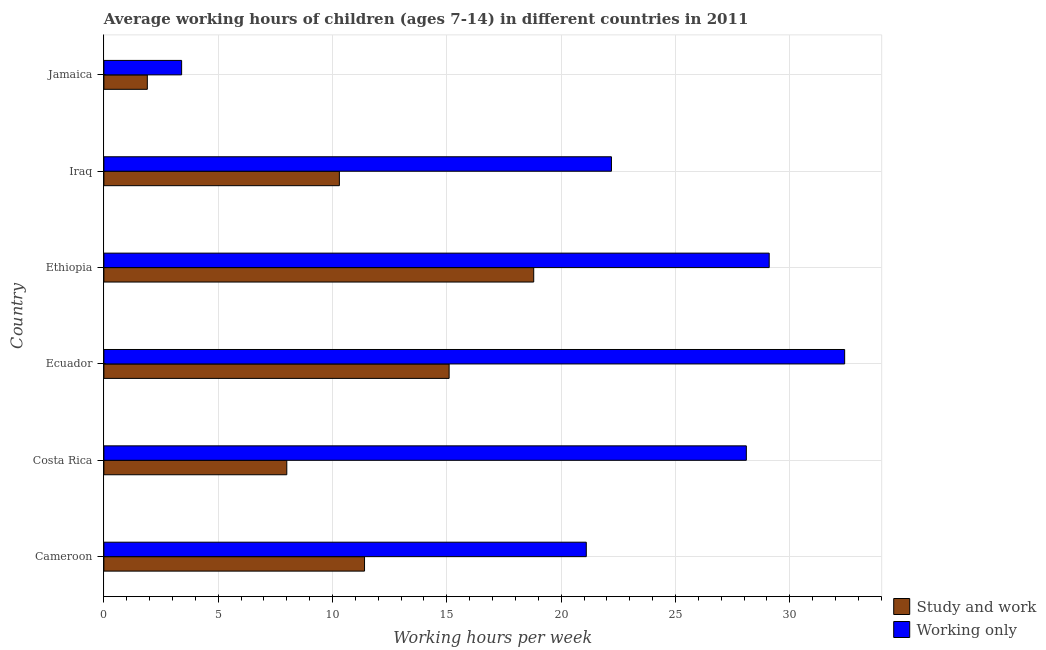Are the number of bars on each tick of the Y-axis equal?
Your response must be concise. Yes. How many bars are there on the 6th tick from the top?
Offer a terse response. 2. What is the label of the 2nd group of bars from the top?
Provide a short and direct response. Iraq. In how many cases, is the number of bars for a given country not equal to the number of legend labels?
Ensure brevity in your answer.  0. What is the average working hour of children involved in study and work in Jamaica?
Provide a short and direct response. 1.9. Across all countries, what is the minimum average working hour of children involved in only work?
Keep it short and to the point. 3.4. In which country was the average working hour of children involved in only work maximum?
Keep it short and to the point. Ecuador. In which country was the average working hour of children involved in only work minimum?
Your answer should be compact. Jamaica. What is the total average working hour of children involved in study and work in the graph?
Ensure brevity in your answer.  65.5. What is the difference between the average working hour of children involved in only work in Ecuador and that in Jamaica?
Your response must be concise. 29. What is the difference between the average working hour of children involved in only work in Ecuador and the average working hour of children involved in study and work in Costa Rica?
Make the answer very short. 24.4. What is the average average working hour of children involved in only work per country?
Provide a succinct answer. 22.72. In how many countries, is the average working hour of children involved in only work greater than 31 hours?
Keep it short and to the point. 1. What is the ratio of the average working hour of children involved in study and work in Costa Rica to that in Iraq?
Offer a very short reply. 0.78. What is the difference between the highest and the second highest average working hour of children involved in study and work?
Your response must be concise. 3.7. Is the sum of the average working hour of children involved in only work in Costa Rica and Jamaica greater than the maximum average working hour of children involved in study and work across all countries?
Your answer should be very brief. Yes. What does the 2nd bar from the top in Iraq represents?
Provide a short and direct response. Study and work. What does the 2nd bar from the bottom in Ecuador represents?
Ensure brevity in your answer.  Working only. How many bars are there?
Offer a very short reply. 12. Are all the bars in the graph horizontal?
Your response must be concise. Yes. How many countries are there in the graph?
Ensure brevity in your answer.  6. What is the difference between two consecutive major ticks on the X-axis?
Give a very brief answer. 5. Does the graph contain grids?
Provide a succinct answer. Yes. How are the legend labels stacked?
Make the answer very short. Vertical. What is the title of the graph?
Provide a succinct answer. Average working hours of children (ages 7-14) in different countries in 2011. Does "State government" appear as one of the legend labels in the graph?
Provide a succinct answer. No. What is the label or title of the X-axis?
Provide a succinct answer. Working hours per week. What is the Working hours per week in Study and work in Cameroon?
Keep it short and to the point. 11.4. What is the Working hours per week of Working only in Cameroon?
Provide a succinct answer. 21.1. What is the Working hours per week of Study and work in Costa Rica?
Offer a terse response. 8. What is the Working hours per week in Working only in Costa Rica?
Provide a succinct answer. 28.1. What is the Working hours per week of Working only in Ecuador?
Offer a very short reply. 32.4. What is the Working hours per week in Working only in Ethiopia?
Your answer should be very brief. 29.1. What is the Working hours per week of Working only in Jamaica?
Your answer should be very brief. 3.4. Across all countries, what is the maximum Working hours per week in Working only?
Your answer should be very brief. 32.4. What is the total Working hours per week of Study and work in the graph?
Your response must be concise. 65.5. What is the total Working hours per week of Working only in the graph?
Your answer should be very brief. 136.3. What is the difference between the Working hours per week of Study and work in Cameroon and that in Costa Rica?
Your answer should be very brief. 3.4. What is the difference between the Working hours per week in Working only in Cameroon and that in Costa Rica?
Give a very brief answer. -7. What is the difference between the Working hours per week in Study and work in Cameroon and that in Ethiopia?
Your response must be concise. -7.4. What is the difference between the Working hours per week of Working only in Cameroon and that in Iraq?
Ensure brevity in your answer.  -1.1. What is the difference between the Working hours per week of Study and work in Cameroon and that in Jamaica?
Offer a very short reply. 9.5. What is the difference between the Working hours per week of Working only in Cameroon and that in Jamaica?
Provide a short and direct response. 17.7. What is the difference between the Working hours per week in Study and work in Costa Rica and that in Ecuador?
Offer a very short reply. -7.1. What is the difference between the Working hours per week in Working only in Costa Rica and that in Ecuador?
Your response must be concise. -4.3. What is the difference between the Working hours per week of Working only in Costa Rica and that in Ethiopia?
Offer a terse response. -1. What is the difference between the Working hours per week in Working only in Costa Rica and that in Iraq?
Give a very brief answer. 5.9. What is the difference between the Working hours per week of Study and work in Costa Rica and that in Jamaica?
Offer a very short reply. 6.1. What is the difference between the Working hours per week in Working only in Costa Rica and that in Jamaica?
Keep it short and to the point. 24.7. What is the difference between the Working hours per week of Study and work in Ecuador and that in Ethiopia?
Provide a succinct answer. -3.7. What is the difference between the Working hours per week in Study and work in Ethiopia and that in Iraq?
Offer a terse response. 8.5. What is the difference between the Working hours per week in Working only in Ethiopia and that in Jamaica?
Ensure brevity in your answer.  25.7. What is the difference between the Working hours per week of Study and work in Iraq and that in Jamaica?
Ensure brevity in your answer.  8.4. What is the difference between the Working hours per week of Study and work in Cameroon and the Working hours per week of Working only in Costa Rica?
Your answer should be very brief. -16.7. What is the difference between the Working hours per week of Study and work in Cameroon and the Working hours per week of Working only in Ecuador?
Make the answer very short. -21. What is the difference between the Working hours per week of Study and work in Cameroon and the Working hours per week of Working only in Ethiopia?
Ensure brevity in your answer.  -17.7. What is the difference between the Working hours per week of Study and work in Costa Rica and the Working hours per week of Working only in Ecuador?
Give a very brief answer. -24.4. What is the difference between the Working hours per week in Study and work in Costa Rica and the Working hours per week in Working only in Ethiopia?
Keep it short and to the point. -21.1. What is the difference between the Working hours per week of Study and work in Costa Rica and the Working hours per week of Working only in Iraq?
Offer a very short reply. -14.2. What is the difference between the Working hours per week in Study and work in Ecuador and the Working hours per week in Working only in Ethiopia?
Your answer should be very brief. -14. What is the difference between the Working hours per week of Study and work in Ecuador and the Working hours per week of Working only in Jamaica?
Your response must be concise. 11.7. What is the difference between the Working hours per week in Study and work in Ethiopia and the Working hours per week in Working only in Iraq?
Ensure brevity in your answer.  -3.4. What is the average Working hours per week of Study and work per country?
Your answer should be compact. 10.92. What is the average Working hours per week in Working only per country?
Make the answer very short. 22.72. What is the difference between the Working hours per week of Study and work and Working hours per week of Working only in Cameroon?
Offer a very short reply. -9.7. What is the difference between the Working hours per week in Study and work and Working hours per week in Working only in Costa Rica?
Provide a short and direct response. -20.1. What is the difference between the Working hours per week of Study and work and Working hours per week of Working only in Ecuador?
Your answer should be very brief. -17.3. What is the difference between the Working hours per week of Study and work and Working hours per week of Working only in Ethiopia?
Offer a very short reply. -10.3. What is the ratio of the Working hours per week of Study and work in Cameroon to that in Costa Rica?
Provide a succinct answer. 1.43. What is the ratio of the Working hours per week in Working only in Cameroon to that in Costa Rica?
Offer a very short reply. 0.75. What is the ratio of the Working hours per week of Study and work in Cameroon to that in Ecuador?
Your answer should be compact. 0.76. What is the ratio of the Working hours per week of Working only in Cameroon to that in Ecuador?
Your answer should be very brief. 0.65. What is the ratio of the Working hours per week in Study and work in Cameroon to that in Ethiopia?
Your answer should be compact. 0.61. What is the ratio of the Working hours per week in Working only in Cameroon to that in Ethiopia?
Give a very brief answer. 0.73. What is the ratio of the Working hours per week in Study and work in Cameroon to that in Iraq?
Offer a very short reply. 1.11. What is the ratio of the Working hours per week of Working only in Cameroon to that in Iraq?
Offer a terse response. 0.95. What is the ratio of the Working hours per week of Working only in Cameroon to that in Jamaica?
Provide a short and direct response. 6.21. What is the ratio of the Working hours per week in Study and work in Costa Rica to that in Ecuador?
Provide a short and direct response. 0.53. What is the ratio of the Working hours per week in Working only in Costa Rica to that in Ecuador?
Offer a very short reply. 0.87. What is the ratio of the Working hours per week in Study and work in Costa Rica to that in Ethiopia?
Give a very brief answer. 0.43. What is the ratio of the Working hours per week in Working only in Costa Rica to that in Ethiopia?
Make the answer very short. 0.97. What is the ratio of the Working hours per week of Study and work in Costa Rica to that in Iraq?
Ensure brevity in your answer.  0.78. What is the ratio of the Working hours per week in Working only in Costa Rica to that in Iraq?
Ensure brevity in your answer.  1.27. What is the ratio of the Working hours per week of Study and work in Costa Rica to that in Jamaica?
Ensure brevity in your answer.  4.21. What is the ratio of the Working hours per week in Working only in Costa Rica to that in Jamaica?
Offer a terse response. 8.26. What is the ratio of the Working hours per week of Study and work in Ecuador to that in Ethiopia?
Keep it short and to the point. 0.8. What is the ratio of the Working hours per week of Working only in Ecuador to that in Ethiopia?
Offer a terse response. 1.11. What is the ratio of the Working hours per week in Study and work in Ecuador to that in Iraq?
Ensure brevity in your answer.  1.47. What is the ratio of the Working hours per week in Working only in Ecuador to that in Iraq?
Keep it short and to the point. 1.46. What is the ratio of the Working hours per week in Study and work in Ecuador to that in Jamaica?
Keep it short and to the point. 7.95. What is the ratio of the Working hours per week in Working only in Ecuador to that in Jamaica?
Offer a very short reply. 9.53. What is the ratio of the Working hours per week of Study and work in Ethiopia to that in Iraq?
Offer a terse response. 1.83. What is the ratio of the Working hours per week of Working only in Ethiopia to that in Iraq?
Your answer should be compact. 1.31. What is the ratio of the Working hours per week in Study and work in Ethiopia to that in Jamaica?
Provide a succinct answer. 9.89. What is the ratio of the Working hours per week of Working only in Ethiopia to that in Jamaica?
Offer a very short reply. 8.56. What is the ratio of the Working hours per week in Study and work in Iraq to that in Jamaica?
Ensure brevity in your answer.  5.42. What is the ratio of the Working hours per week of Working only in Iraq to that in Jamaica?
Provide a succinct answer. 6.53. What is the difference between the highest and the second highest Working hours per week of Study and work?
Make the answer very short. 3.7. What is the difference between the highest and the second highest Working hours per week of Working only?
Keep it short and to the point. 3.3. What is the difference between the highest and the lowest Working hours per week in Working only?
Your response must be concise. 29. 